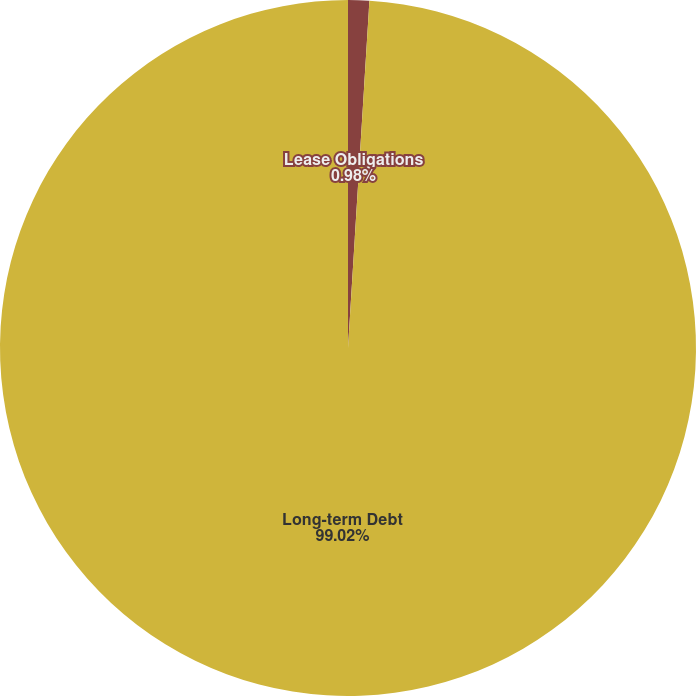<chart> <loc_0><loc_0><loc_500><loc_500><pie_chart><fcel>Lease Obligations<fcel>Long-term Debt<nl><fcel>0.98%<fcel>99.02%<nl></chart> 